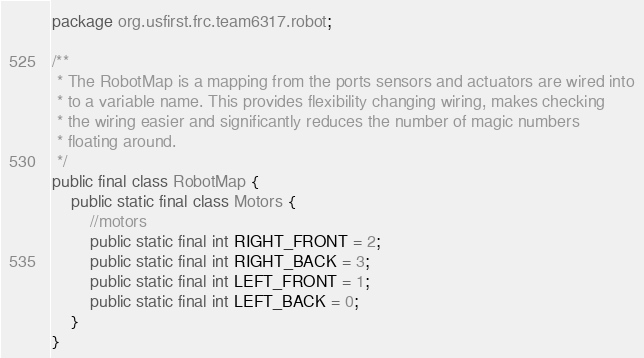<code> <loc_0><loc_0><loc_500><loc_500><_Java_>package org.usfirst.frc.team6317.robot;

/**
 * The RobotMap is a mapping from the ports sensors and actuators are wired into
 * to a variable name. This provides flexibility changing wiring, makes checking
 * the wiring easier and significantly reduces the number of magic numbers
 * floating around.
 */
public final class RobotMap {
	public static final class Motors {
		//motors
		public static final int RIGHT_FRONT = 2;
		public static final int RIGHT_BACK = 3;
		public static final int LEFT_FRONT = 1;
		public static final int LEFT_BACK = 0;
	}
}
</code> 